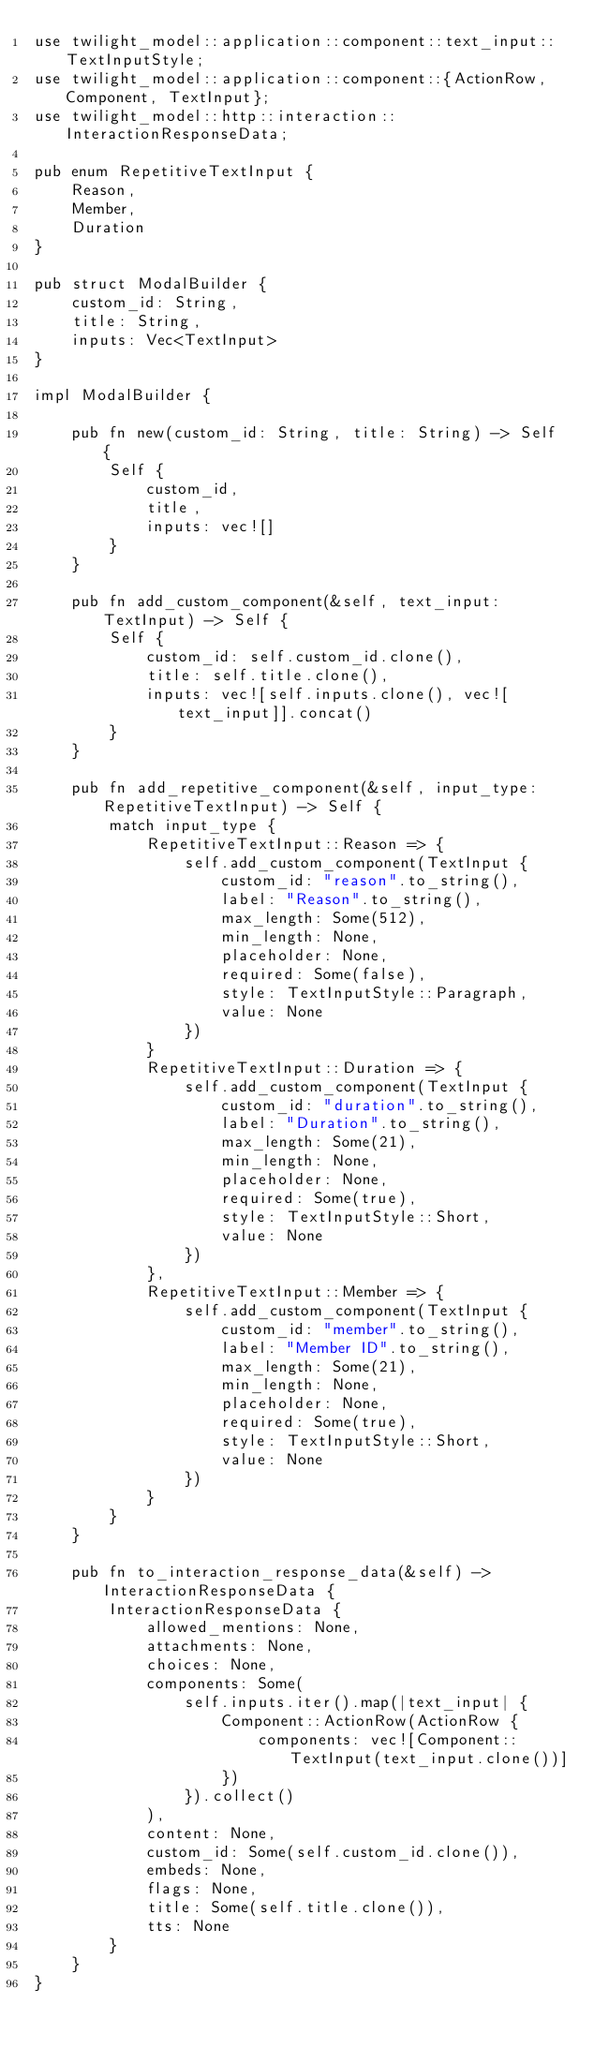Convert code to text. <code><loc_0><loc_0><loc_500><loc_500><_Rust_>use twilight_model::application::component::text_input::TextInputStyle;
use twilight_model::application::component::{ActionRow, Component, TextInput};
use twilight_model::http::interaction::InteractionResponseData;

pub enum RepetitiveTextInput {
    Reason,
    Member,
    Duration
}

pub struct ModalBuilder {
    custom_id: String,
    title: String,
    inputs: Vec<TextInput>
}

impl ModalBuilder {

    pub fn new(custom_id: String, title: String) -> Self {
        Self {
            custom_id,
            title,
            inputs: vec![]
        }
    }

    pub fn add_custom_component(&self, text_input: TextInput) -> Self {
        Self {
            custom_id: self.custom_id.clone(),
            title: self.title.clone(),
            inputs: vec![self.inputs.clone(), vec![text_input]].concat()
        }
    }

    pub fn add_repetitive_component(&self, input_type: RepetitiveTextInput) -> Self {
        match input_type {
            RepetitiveTextInput::Reason => {
                self.add_custom_component(TextInput {
                    custom_id: "reason".to_string(),
                    label: "Reason".to_string(),
                    max_length: Some(512),
                    min_length: None,
                    placeholder: None,
                    required: Some(false),
                    style: TextInputStyle::Paragraph,
                    value: None
                })
            }
            RepetitiveTextInput::Duration => {
                self.add_custom_component(TextInput {
                    custom_id: "duration".to_string(),
                    label: "Duration".to_string(),
                    max_length: Some(21),
                    min_length: None,
                    placeholder: None,
                    required: Some(true),
                    style: TextInputStyle::Short,
                    value: None
                })
            },
            RepetitiveTextInput::Member => {
                self.add_custom_component(TextInput {
                    custom_id: "member".to_string(),
                    label: "Member ID".to_string(),
                    max_length: Some(21),
                    min_length: None,
                    placeholder: None,
                    required: Some(true),
                    style: TextInputStyle::Short,
                    value: None
                })
            }
        }
    }

    pub fn to_interaction_response_data(&self) -> InteractionResponseData {
        InteractionResponseData {
            allowed_mentions: None,
            attachments: None,
            choices: None,
            components: Some(
                self.inputs.iter().map(|text_input| {
                    Component::ActionRow(ActionRow {
                        components: vec![Component::TextInput(text_input.clone())]
                    })
                }).collect()
            ),
            content: None,
            custom_id: Some(self.custom_id.clone()),
            embeds: None,
            flags: None,
            title: Some(self.title.clone()),
            tts: None
        }
    }
}</code> 